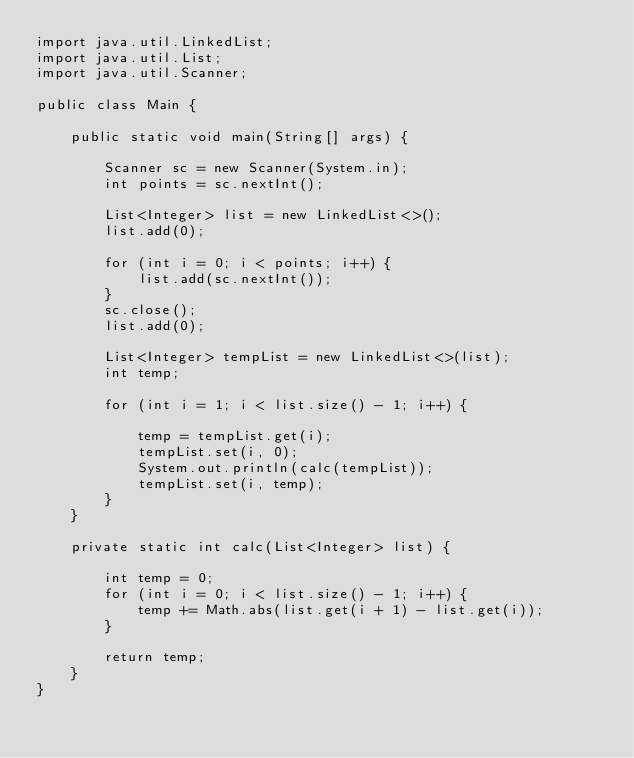<code> <loc_0><loc_0><loc_500><loc_500><_Java_>import java.util.LinkedList;
import java.util.List;
import java.util.Scanner;

public class Main {

	public static void main(String[] args) {

		Scanner sc = new Scanner(System.in);
		int points = sc.nextInt();

		List<Integer> list = new LinkedList<>();
		list.add(0);

		for (int i = 0; i < points; i++) {
			list.add(sc.nextInt());
		}
		sc.close();
		list.add(0);

		List<Integer> tempList = new LinkedList<>(list);
		int temp;

		for (int i = 1; i < list.size() - 1; i++) {

			temp = tempList.get(i);
			tempList.set(i, 0);
			System.out.println(calc(tempList));
			tempList.set(i, temp);
		}
	}

	private static int calc(List<Integer> list) {

		int temp = 0;
		for (int i = 0; i < list.size() - 1; i++) {
			temp += Math.abs(list.get(i + 1) - list.get(i));
		}

		return temp;
	}
}</code> 